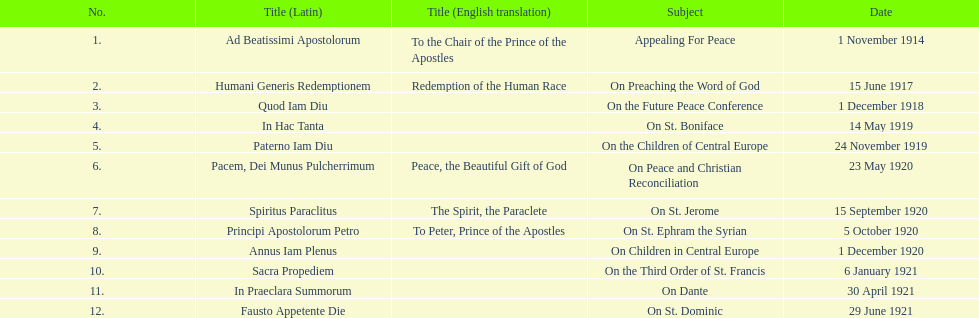What was the number of encyclopedias that had subjects relating specifically to children? 2. 